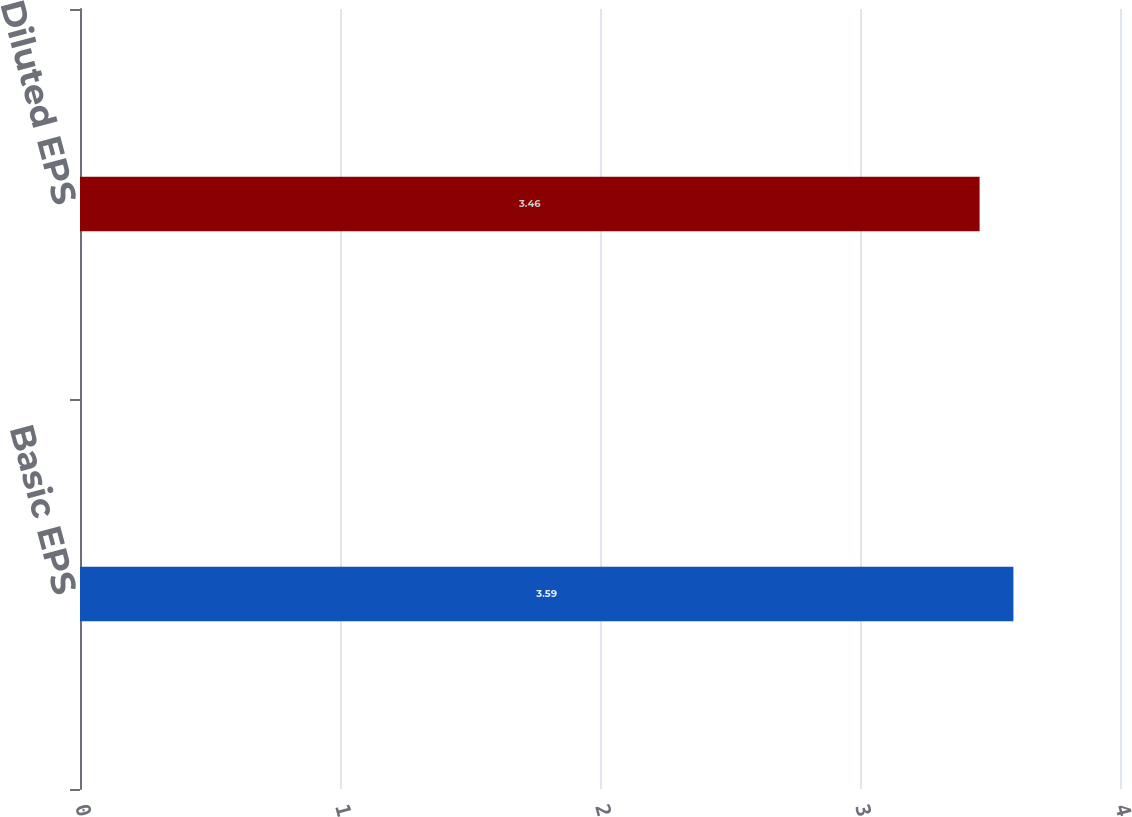Convert chart. <chart><loc_0><loc_0><loc_500><loc_500><bar_chart><fcel>Basic EPS<fcel>Diluted EPS<nl><fcel>3.59<fcel>3.46<nl></chart> 